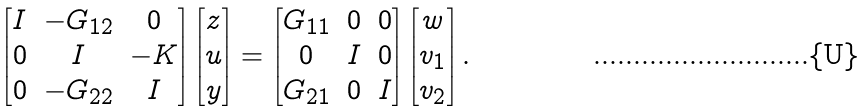<formula> <loc_0><loc_0><loc_500><loc_500>\begin{bmatrix} I & - G _ { 1 2 } & 0 \\ 0 & I & - K \\ 0 & - G _ { 2 2 } & I \end{bmatrix} \begin{bmatrix} z \\ u \\ y \end{bmatrix} = \begin{bmatrix} G _ { 1 1 } & 0 & 0 \\ 0 & I & 0 \\ G _ { 2 1 } & 0 & I \end{bmatrix} \begin{bmatrix} w \\ v _ { 1 } \\ v _ { 2 } \end{bmatrix} .</formula> 